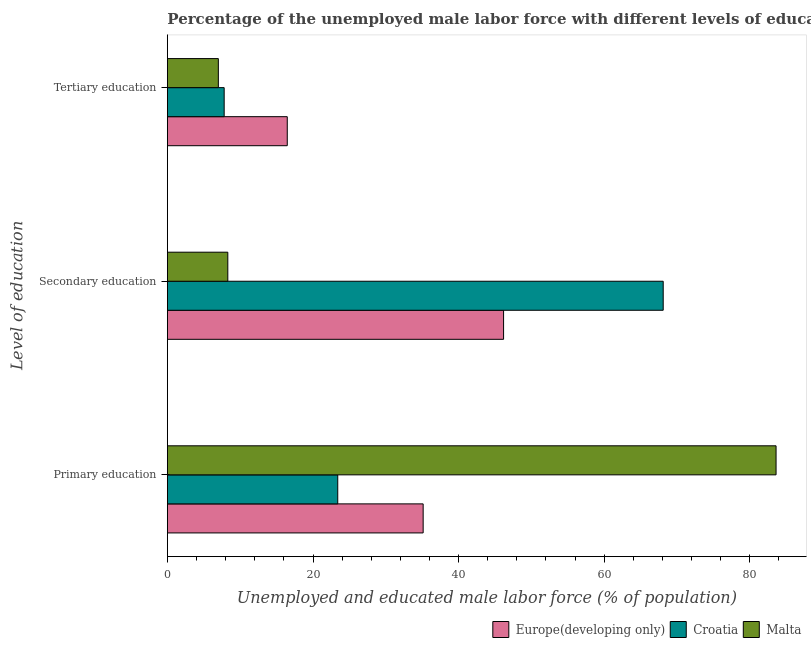How many different coloured bars are there?
Provide a short and direct response. 3. Are the number of bars on each tick of the Y-axis equal?
Provide a succinct answer. Yes. What is the label of the 1st group of bars from the top?
Provide a succinct answer. Tertiary education. What is the percentage of male labor force who received secondary education in Malta?
Offer a terse response. 8.3. Across all countries, what is the maximum percentage of male labor force who received secondary education?
Give a very brief answer. 68.1. In which country was the percentage of male labor force who received tertiary education maximum?
Your response must be concise. Europe(developing only). In which country was the percentage of male labor force who received secondary education minimum?
Offer a terse response. Malta. What is the total percentage of male labor force who received primary education in the graph?
Provide a succinct answer. 142.13. What is the difference between the percentage of male labor force who received secondary education in Malta and that in Europe(developing only)?
Your answer should be very brief. -37.88. What is the difference between the percentage of male labor force who received tertiary education in Malta and the percentage of male labor force who received secondary education in Croatia?
Provide a succinct answer. -61.1. What is the average percentage of male labor force who received secondary education per country?
Ensure brevity in your answer.  40.86. What is the difference between the percentage of male labor force who received primary education and percentage of male labor force who received tertiary education in Malta?
Your response must be concise. 76.6. In how many countries, is the percentage of male labor force who received primary education greater than 64 %?
Ensure brevity in your answer.  1. What is the ratio of the percentage of male labor force who received primary education in Europe(developing only) to that in Malta?
Make the answer very short. 0.42. Is the percentage of male labor force who received primary education in Croatia less than that in Malta?
Your answer should be compact. Yes. What is the difference between the highest and the second highest percentage of male labor force who received tertiary education?
Give a very brief answer. 8.66. What is the difference between the highest and the lowest percentage of male labor force who received tertiary education?
Your response must be concise. 9.46. In how many countries, is the percentage of male labor force who received tertiary education greater than the average percentage of male labor force who received tertiary education taken over all countries?
Provide a short and direct response. 1. Is the sum of the percentage of male labor force who received primary education in Malta and Europe(developing only) greater than the maximum percentage of male labor force who received tertiary education across all countries?
Your response must be concise. Yes. What does the 2nd bar from the top in Primary education represents?
Keep it short and to the point. Croatia. What does the 1st bar from the bottom in Tertiary education represents?
Offer a terse response. Europe(developing only). Is it the case that in every country, the sum of the percentage of male labor force who received primary education and percentage of male labor force who received secondary education is greater than the percentage of male labor force who received tertiary education?
Ensure brevity in your answer.  Yes. Are the values on the major ticks of X-axis written in scientific E-notation?
Your answer should be very brief. No. Does the graph contain any zero values?
Make the answer very short. No. Where does the legend appear in the graph?
Provide a short and direct response. Bottom right. What is the title of the graph?
Offer a terse response. Percentage of the unemployed male labor force with different levels of education in countries. What is the label or title of the X-axis?
Provide a succinct answer. Unemployed and educated male labor force (% of population). What is the label or title of the Y-axis?
Ensure brevity in your answer.  Level of education. What is the Unemployed and educated male labor force (% of population) of Europe(developing only) in Primary education?
Ensure brevity in your answer.  35.13. What is the Unemployed and educated male labor force (% of population) of Croatia in Primary education?
Your response must be concise. 23.4. What is the Unemployed and educated male labor force (% of population) in Malta in Primary education?
Your response must be concise. 83.6. What is the Unemployed and educated male labor force (% of population) of Europe(developing only) in Secondary education?
Make the answer very short. 46.18. What is the Unemployed and educated male labor force (% of population) of Croatia in Secondary education?
Your answer should be compact. 68.1. What is the Unemployed and educated male labor force (% of population) of Malta in Secondary education?
Make the answer very short. 8.3. What is the Unemployed and educated male labor force (% of population) in Europe(developing only) in Tertiary education?
Keep it short and to the point. 16.46. What is the Unemployed and educated male labor force (% of population) in Croatia in Tertiary education?
Ensure brevity in your answer.  7.8. Across all Level of education, what is the maximum Unemployed and educated male labor force (% of population) of Europe(developing only)?
Ensure brevity in your answer.  46.18. Across all Level of education, what is the maximum Unemployed and educated male labor force (% of population) of Croatia?
Ensure brevity in your answer.  68.1. Across all Level of education, what is the maximum Unemployed and educated male labor force (% of population) in Malta?
Provide a short and direct response. 83.6. Across all Level of education, what is the minimum Unemployed and educated male labor force (% of population) in Europe(developing only)?
Offer a terse response. 16.46. Across all Level of education, what is the minimum Unemployed and educated male labor force (% of population) of Croatia?
Your answer should be compact. 7.8. Across all Level of education, what is the minimum Unemployed and educated male labor force (% of population) in Malta?
Keep it short and to the point. 7. What is the total Unemployed and educated male labor force (% of population) in Europe(developing only) in the graph?
Ensure brevity in your answer.  97.77. What is the total Unemployed and educated male labor force (% of population) in Croatia in the graph?
Your answer should be very brief. 99.3. What is the total Unemployed and educated male labor force (% of population) in Malta in the graph?
Keep it short and to the point. 98.9. What is the difference between the Unemployed and educated male labor force (% of population) of Europe(developing only) in Primary education and that in Secondary education?
Offer a terse response. -11.05. What is the difference between the Unemployed and educated male labor force (% of population) of Croatia in Primary education and that in Secondary education?
Make the answer very short. -44.7. What is the difference between the Unemployed and educated male labor force (% of population) in Malta in Primary education and that in Secondary education?
Offer a very short reply. 75.3. What is the difference between the Unemployed and educated male labor force (% of population) in Europe(developing only) in Primary education and that in Tertiary education?
Give a very brief answer. 18.66. What is the difference between the Unemployed and educated male labor force (% of population) in Malta in Primary education and that in Tertiary education?
Provide a succinct answer. 76.6. What is the difference between the Unemployed and educated male labor force (% of population) in Europe(developing only) in Secondary education and that in Tertiary education?
Your answer should be very brief. 29.71. What is the difference between the Unemployed and educated male labor force (% of population) in Croatia in Secondary education and that in Tertiary education?
Provide a succinct answer. 60.3. What is the difference between the Unemployed and educated male labor force (% of population) in Europe(developing only) in Primary education and the Unemployed and educated male labor force (% of population) in Croatia in Secondary education?
Your answer should be very brief. -32.97. What is the difference between the Unemployed and educated male labor force (% of population) in Europe(developing only) in Primary education and the Unemployed and educated male labor force (% of population) in Malta in Secondary education?
Ensure brevity in your answer.  26.83. What is the difference between the Unemployed and educated male labor force (% of population) of Croatia in Primary education and the Unemployed and educated male labor force (% of population) of Malta in Secondary education?
Ensure brevity in your answer.  15.1. What is the difference between the Unemployed and educated male labor force (% of population) in Europe(developing only) in Primary education and the Unemployed and educated male labor force (% of population) in Croatia in Tertiary education?
Provide a short and direct response. 27.33. What is the difference between the Unemployed and educated male labor force (% of population) of Europe(developing only) in Primary education and the Unemployed and educated male labor force (% of population) of Malta in Tertiary education?
Provide a short and direct response. 28.13. What is the difference between the Unemployed and educated male labor force (% of population) of Croatia in Primary education and the Unemployed and educated male labor force (% of population) of Malta in Tertiary education?
Provide a succinct answer. 16.4. What is the difference between the Unemployed and educated male labor force (% of population) in Europe(developing only) in Secondary education and the Unemployed and educated male labor force (% of population) in Croatia in Tertiary education?
Your answer should be compact. 38.38. What is the difference between the Unemployed and educated male labor force (% of population) in Europe(developing only) in Secondary education and the Unemployed and educated male labor force (% of population) in Malta in Tertiary education?
Your response must be concise. 39.18. What is the difference between the Unemployed and educated male labor force (% of population) of Croatia in Secondary education and the Unemployed and educated male labor force (% of population) of Malta in Tertiary education?
Your answer should be compact. 61.1. What is the average Unemployed and educated male labor force (% of population) of Europe(developing only) per Level of education?
Keep it short and to the point. 32.59. What is the average Unemployed and educated male labor force (% of population) of Croatia per Level of education?
Provide a short and direct response. 33.1. What is the average Unemployed and educated male labor force (% of population) in Malta per Level of education?
Provide a succinct answer. 32.97. What is the difference between the Unemployed and educated male labor force (% of population) of Europe(developing only) and Unemployed and educated male labor force (% of population) of Croatia in Primary education?
Your answer should be compact. 11.73. What is the difference between the Unemployed and educated male labor force (% of population) of Europe(developing only) and Unemployed and educated male labor force (% of population) of Malta in Primary education?
Provide a short and direct response. -48.47. What is the difference between the Unemployed and educated male labor force (% of population) in Croatia and Unemployed and educated male labor force (% of population) in Malta in Primary education?
Provide a succinct answer. -60.2. What is the difference between the Unemployed and educated male labor force (% of population) of Europe(developing only) and Unemployed and educated male labor force (% of population) of Croatia in Secondary education?
Provide a short and direct response. -21.92. What is the difference between the Unemployed and educated male labor force (% of population) of Europe(developing only) and Unemployed and educated male labor force (% of population) of Malta in Secondary education?
Ensure brevity in your answer.  37.88. What is the difference between the Unemployed and educated male labor force (% of population) of Croatia and Unemployed and educated male labor force (% of population) of Malta in Secondary education?
Ensure brevity in your answer.  59.8. What is the difference between the Unemployed and educated male labor force (% of population) of Europe(developing only) and Unemployed and educated male labor force (% of population) of Croatia in Tertiary education?
Provide a succinct answer. 8.66. What is the difference between the Unemployed and educated male labor force (% of population) in Europe(developing only) and Unemployed and educated male labor force (% of population) in Malta in Tertiary education?
Offer a very short reply. 9.46. What is the difference between the Unemployed and educated male labor force (% of population) in Croatia and Unemployed and educated male labor force (% of population) in Malta in Tertiary education?
Ensure brevity in your answer.  0.8. What is the ratio of the Unemployed and educated male labor force (% of population) of Europe(developing only) in Primary education to that in Secondary education?
Offer a terse response. 0.76. What is the ratio of the Unemployed and educated male labor force (% of population) of Croatia in Primary education to that in Secondary education?
Offer a terse response. 0.34. What is the ratio of the Unemployed and educated male labor force (% of population) of Malta in Primary education to that in Secondary education?
Your answer should be compact. 10.07. What is the ratio of the Unemployed and educated male labor force (% of population) of Europe(developing only) in Primary education to that in Tertiary education?
Offer a terse response. 2.13. What is the ratio of the Unemployed and educated male labor force (% of population) of Croatia in Primary education to that in Tertiary education?
Ensure brevity in your answer.  3. What is the ratio of the Unemployed and educated male labor force (% of population) in Malta in Primary education to that in Tertiary education?
Your answer should be compact. 11.94. What is the ratio of the Unemployed and educated male labor force (% of population) of Europe(developing only) in Secondary education to that in Tertiary education?
Provide a short and direct response. 2.8. What is the ratio of the Unemployed and educated male labor force (% of population) of Croatia in Secondary education to that in Tertiary education?
Your response must be concise. 8.73. What is the ratio of the Unemployed and educated male labor force (% of population) of Malta in Secondary education to that in Tertiary education?
Your answer should be very brief. 1.19. What is the difference between the highest and the second highest Unemployed and educated male labor force (% of population) in Europe(developing only)?
Make the answer very short. 11.05. What is the difference between the highest and the second highest Unemployed and educated male labor force (% of population) of Croatia?
Your answer should be compact. 44.7. What is the difference between the highest and the second highest Unemployed and educated male labor force (% of population) in Malta?
Offer a terse response. 75.3. What is the difference between the highest and the lowest Unemployed and educated male labor force (% of population) in Europe(developing only)?
Your response must be concise. 29.71. What is the difference between the highest and the lowest Unemployed and educated male labor force (% of population) of Croatia?
Offer a terse response. 60.3. What is the difference between the highest and the lowest Unemployed and educated male labor force (% of population) in Malta?
Keep it short and to the point. 76.6. 